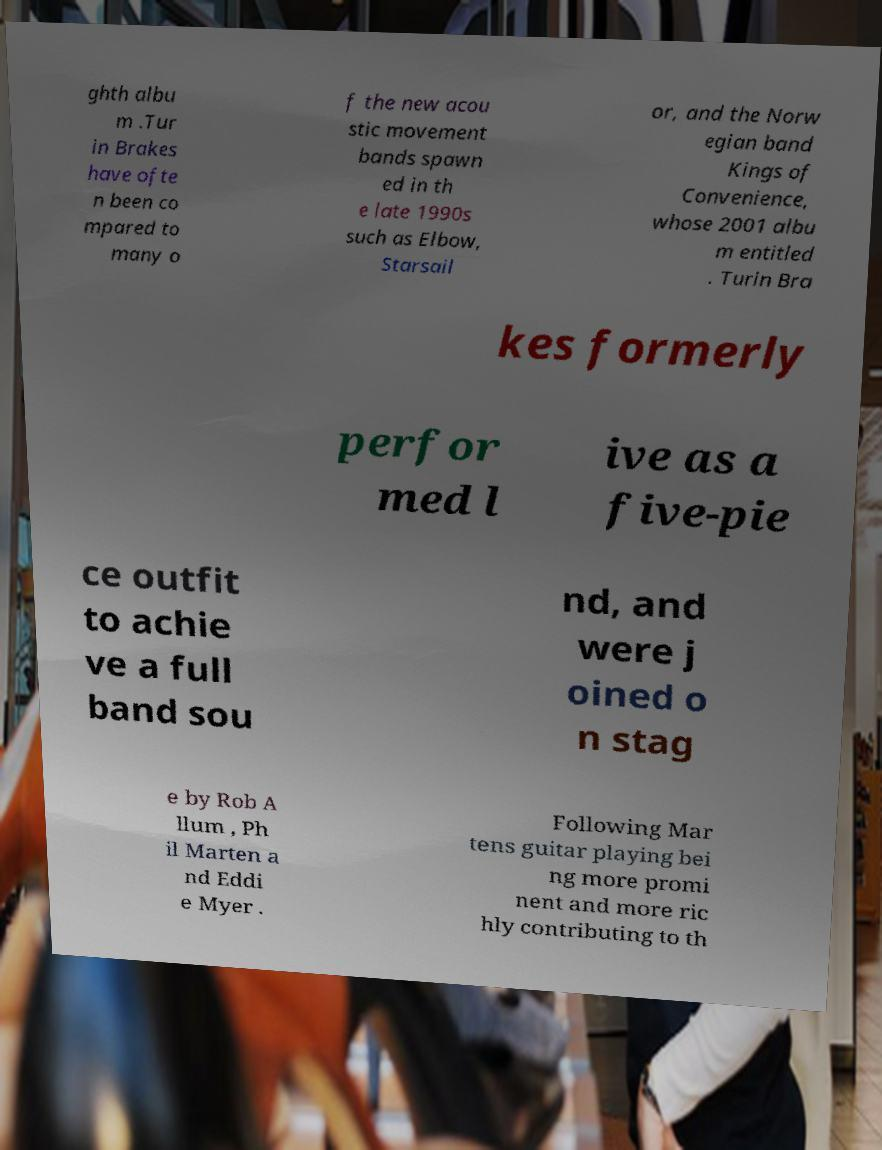Please read and relay the text visible in this image. What does it say? ghth albu m .Tur in Brakes have ofte n been co mpared to many o f the new acou stic movement bands spawn ed in th e late 1990s such as Elbow, Starsail or, and the Norw egian band Kings of Convenience, whose 2001 albu m entitled . Turin Bra kes formerly perfor med l ive as a five-pie ce outfit to achie ve a full band sou nd, and were j oined o n stag e by Rob A llum , Ph il Marten a nd Eddi e Myer . Following Mar tens guitar playing bei ng more promi nent and more ric hly contributing to th 